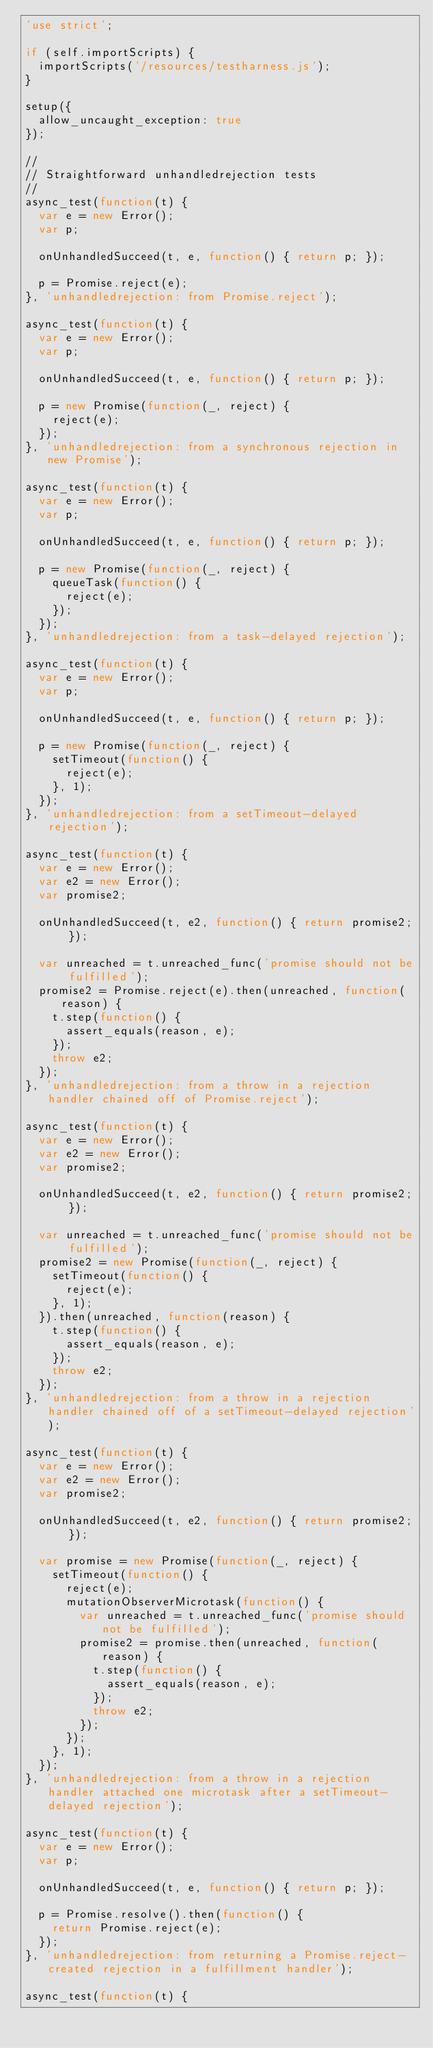<code> <loc_0><loc_0><loc_500><loc_500><_JavaScript_>'use strict';

if (self.importScripts) {
  importScripts('/resources/testharness.js');
}

setup({
  allow_uncaught_exception: true
});

//
// Straightforward unhandledrejection tests
//
async_test(function(t) {
  var e = new Error();
  var p;

  onUnhandledSucceed(t, e, function() { return p; });

  p = Promise.reject(e);
}, 'unhandledrejection: from Promise.reject');

async_test(function(t) {
  var e = new Error();
  var p;

  onUnhandledSucceed(t, e, function() { return p; });

  p = new Promise(function(_, reject) {
    reject(e);
  });
}, 'unhandledrejection: from a synchronous rejection in new Promise');

async_test(function(t) {
  var e = new Error();
  var p;

  onUnhandledSucceed(t, e, function() { return p; });

  p = new Promise(function(_, reject) {
    queueTask(function() {
      reject(e);
    });
  });
}, 'unhandledrejection: from a task-delayed rejection');

async_test(function(t) {
  var e = new Error();
  var p;

  onUnhandledSucceed(t, e, function() { return p; });

  p = new Promise(function(_, reject) {
    setTimeout(function() {
      reject(e);
    }, 1);
  });
}, 'unhandledrejection: from a setTimeout-delayed rejection');

async_test(function(t) {
  var e = new Error();
  var e2 = new Error();
  var promise2;

  onUnhandledSucceed(t, e2, function() { return promise2; });

  var unreached = t.unreached_func('promise should not be fulfilled');
  promise2 = Promise.reject(e).then(unreached, function(reason) {
    t.step(function() {
      assert_equals(reason, e);
    });
    throw e2;
  });
}, 'unhandledrejection: from a throw in a rejection handler chained off of Promise.reject');

async_test(function(t) {
  var e = new Error();
  var e2 = new Error();
  var promise2;

  onUnhandledSucceed(t, e2, function() { return promise2; });

  var unreached = t.unreached_func('promise should not be fulfilled');
  promise2 = new Promise(function(_, reject) {
    setTimeout(function() {
      reject(e);
    }, 1);
  }).then(unreached, function(reason) {
    t.step(function() {
      assert_equals(reason, e);
    });
    throw e2;
  });
}, 'unhandledrejection: from a throw in a rejection handler chained off of a setTimeout-delayed rejection');

async_test(function(t) {
  var e = new Error();
  var e2 = new Error();
  var promise2;

  onUnhandledSucceed(t, e2, function() { return promise2; });

  var promise = new Promise(function(_, reject) {
    setTimeout(function() {
      reject(e);
      mutationObserverMicrotask(function() {
        var unreached = t.unreached_func('promise should not be fulfilled');
        promise2 = promise.then(unreached, function(reason) {
          t.step(function() {
            assert_equals(reason, e);
          });
          throw e2;
        });
      });
    }, 1);
  });
}, 'unhandledrejection: from a throw in a rejection handler attached one microtask after a setTimeout-delayed rejection');

async_test(function(t) {
  var e = new Error();
  var p;

  onUnhandledSucceed(t, e, function() { return p; });

  p = Promise.resolve().then(function() {
    return Promise.reject(e);
  });
}, 'unhandledrejection: from returning a Promise.reject-created rejection in a fulfillment handler');

async_test(function(t) {</code> 